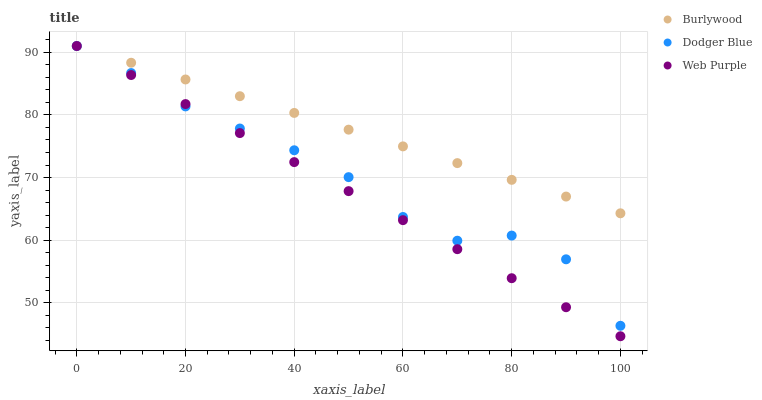Does Web Purple have the minimum area under the curve?
Answer yes or no. Yes. Does Burlywood have the maximum area under the curve?
Answer yes or no. Yes. Does Dodger Blue have the minimum area under the curve?
Answer yes or no. No. Does Dodger Blue have the maximum area under the curve?
Answer yes or no. No. Is Burlywood the smoothest?
Answer yes or no. Yes. Is Dodger Blue the roughest?
Answer yes or no. Yes. Is Web Purple the smoothest?
Answer yes or no. No. Is Web Purple the roughest?
Answer yes or no. No. Does Web Purple have the lowest value?
Answer yes or no. Yes. Does Dodger Blue have the lowest value?
Answer yes or no. No. Does Dodger Blue have the highest value?
Answer yes or no. Yes. Does Burlywood intersect Web Purple?
Answer yes or no. Yes. Is Burlywood less than Web Purple?
Answer yes or no. No. Is Burlywood greater than Web Purple?
Answer yes or no. No. 